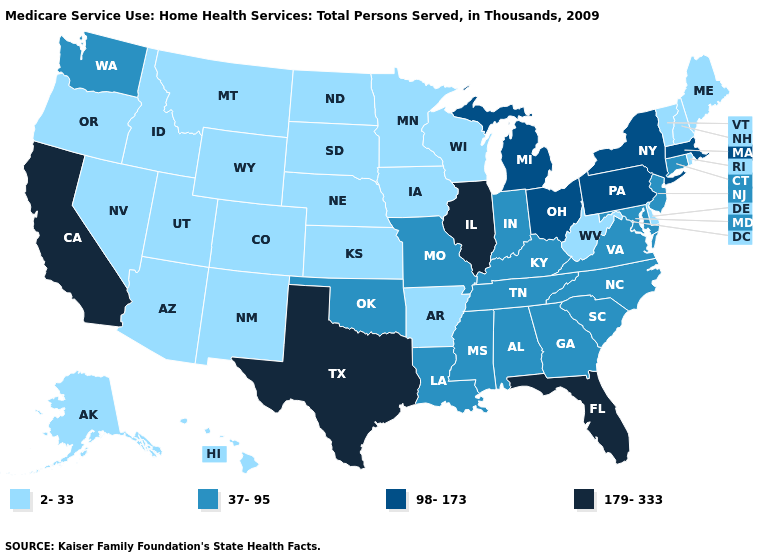What is the lowest value in the Northeast?
Answer briefly. 2-33. Does Hawaii have the lowest value in the USA?
Concise answer only. Yes. Name the states that have a value in the range 37-95?
Answer briefly. Alabama, Connecticut, Georgia, Indiana, Kentucky, Louisiana, Maryland, Mississippi, Missouri, New Jersey, North Carolina, Oklahoma, South Carolina, Tennessee, Virginia, Washington. Which states have the lowest value in the West?
Quick response, please. Alaska, Arizona, Colorado, Hawaii, Idaho, Montana, Nevada, New Mexico, Oregon, Utah, Wyoming. Name the states that have a value in the range 179-333?
Answer briefly. California, Florida, Illinois, Texas. What is the value of Delaware?
Short answer required. 2-33. Does Kentucky have a higher value than Ohio?
Keep it brief. No. What is the value of Connecticut?
Be succinct. 37-95. What is the value of West Virginia?
Give a very brief answer. 2-33. What is the value of Idaho?
Answer briefly. 2-33. Name the states that have a value in the range 98-173?
Keep it brief. Massachusetts, Michigan, New York, Ohio, Pennsylvania. Does the first symbol in the legend represent the smallest category?
Short answer required. Yes. Which states have the lowest value in the West?
Short answer required. Alaska, Arizona, Colorado, Hawaii, Idaho, Montana, Nevada, New Mexico, Oregon, Utah, Wyoming. Name the states that have a value in the range 2-33?
Quick response, please. Alaska, Arizona, Arkansas, Colorado, Delaware, Hawaii, Idaho, Iowa, Kansas, Maine, Minnesota, Montana, Nebraska, Nevada, New Hampshire, New Mexico, North Dakota, Oregon, Rhode Island, South Dakota, Utah, Vermont, West Virginia, Wisconsin, Wyoming. What is the value of California?
Give a very brief answer. 179-333. 